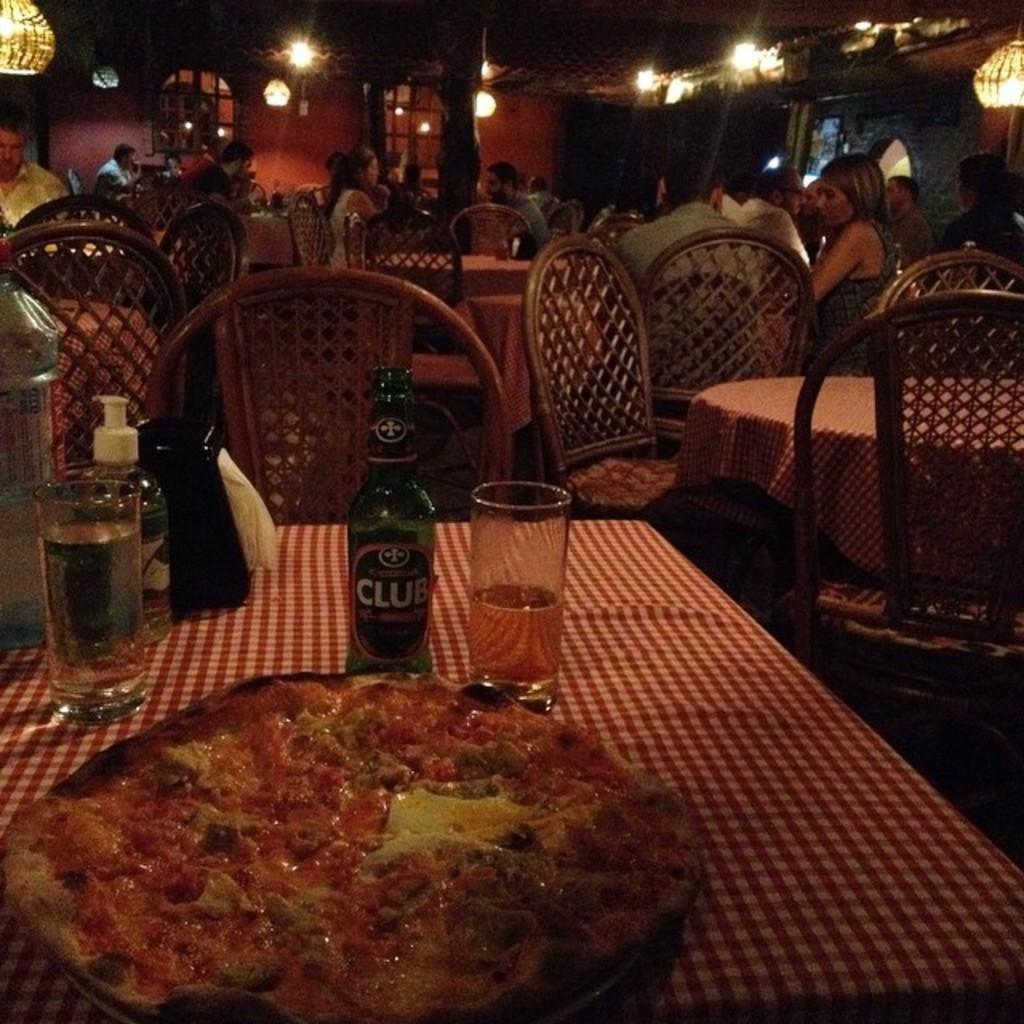In one or two sentences, can you explain what this image depicts? This is a picture taken in a restaurant, there are a group of people sitting on a chair. This is a table on the table there is a glass, bottle, tissue and a food item. Background of this people is a wall and lights. 